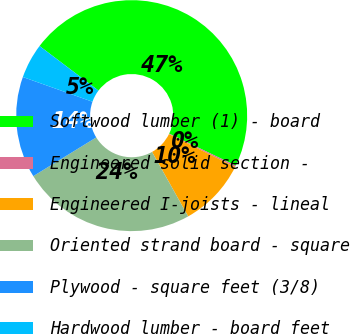Convert chart to OTSL. <chart><loc_0><loc_0><loc_500><loc_500><pie_chart><fcel>Softwood lumber (1) - board<fcel>Engineered solid section -<fcel>Engineered I-joists - lineal<fcel>Oriented strand board - square<fcel>Plywood - square feet (3/8)<fcel>Hardwood lumber - board feet<nl><fcel>46.82%<fcel>0.21%<fcel>9.53%<fcel>24.36%<fcel>14.2%<fcel>4.87%<nl></chart> 